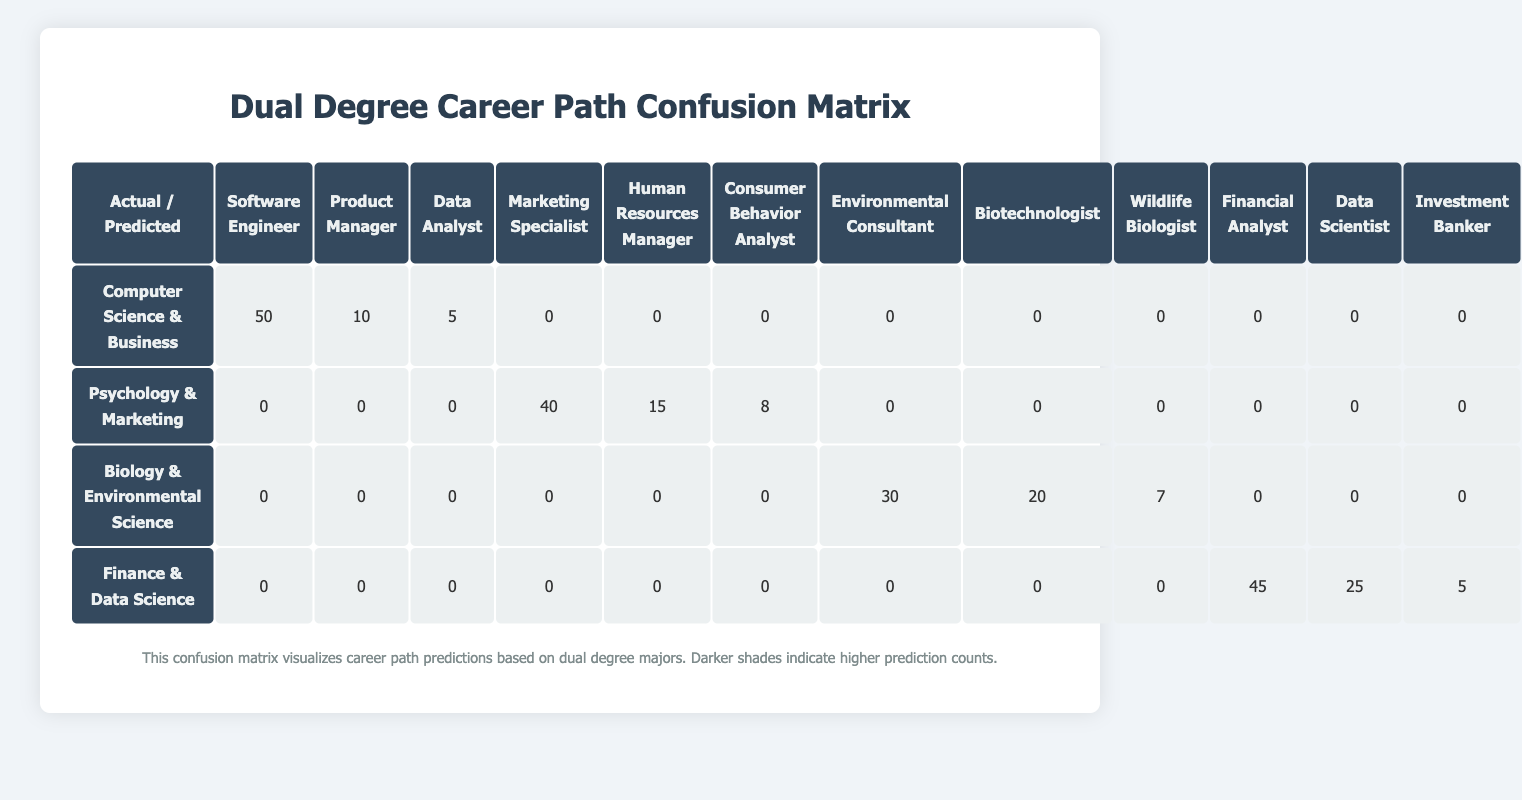What is the predicted career path for students majoring in Computer Science & Business? The career path with the highest count for students majoring in Computer Science & Business is Software Engineer, with a count of 50.
Answer: Software Engineer How many students are predicted to become Data Scientists from Finance & Data Science majors? The predicted count for the Data Scientist career path from Finance & Data Science majors is 25.
Answer: 25 Are there any predictions for students with a Psychology & Marketing major to become Software Engineers? According to the table, the count for Software Engineer predictions for Psychology & Marketing majors is 0.
Answer: No What is the total number of students predicted to become Marketing Specialists or Human Resources Managers from Psychology & Marketing majors? The count for Marketing Specialists is 40 and for Human Resources Managers is 15. Therefore, the total is 40 + 15 = 55.
Answer: 55 Which dual degree major has the highest total number of predicted career paths? For Computer Science & Business, the total count of predicted paths is 65 (50 + 10 + 5), for Psychology & Marketing it is 63 (40 + 15 + 8), for Biology & Environmental Science it is 57 (30 + 20 + 7), and for Finance & Data Science it is 75 (45 + 25 + 5). Finance & Data Science has the highest total.
Answer: Finance & Data Science What is the lowest predicted career path count for any dual degree major? The lowest predicted count in the table is for Investment Banker from Finance & Data Science, which has a count of 5.
Answer: 5 What percentage of students majoring in Biology & Environmental Science are predicted to become Biotechnologists? The count for Biotechnologists is 20, while the total count for that major is 57 (30 + 20 + 7). To get the percentage: (20/57)*100 ≈ 35.09%.
Answer: Approximately 35.09% Is it true that no students from the Biology & Environmental Science major are predicted to become Data Analysts? According to the table, the count for Data Analyst predictions for Biology & Environmental Science majors is 0.
Answer: Yes What is the sum of predicted paths for Environmental Consultant and Wildlife Biologist from Biology & Environmental Science? The count for Environmental Consultant is 30 and for Wildlife Biologist is 7. Therefore, the sum is 30 + 7 = 37.
Answer: 37 